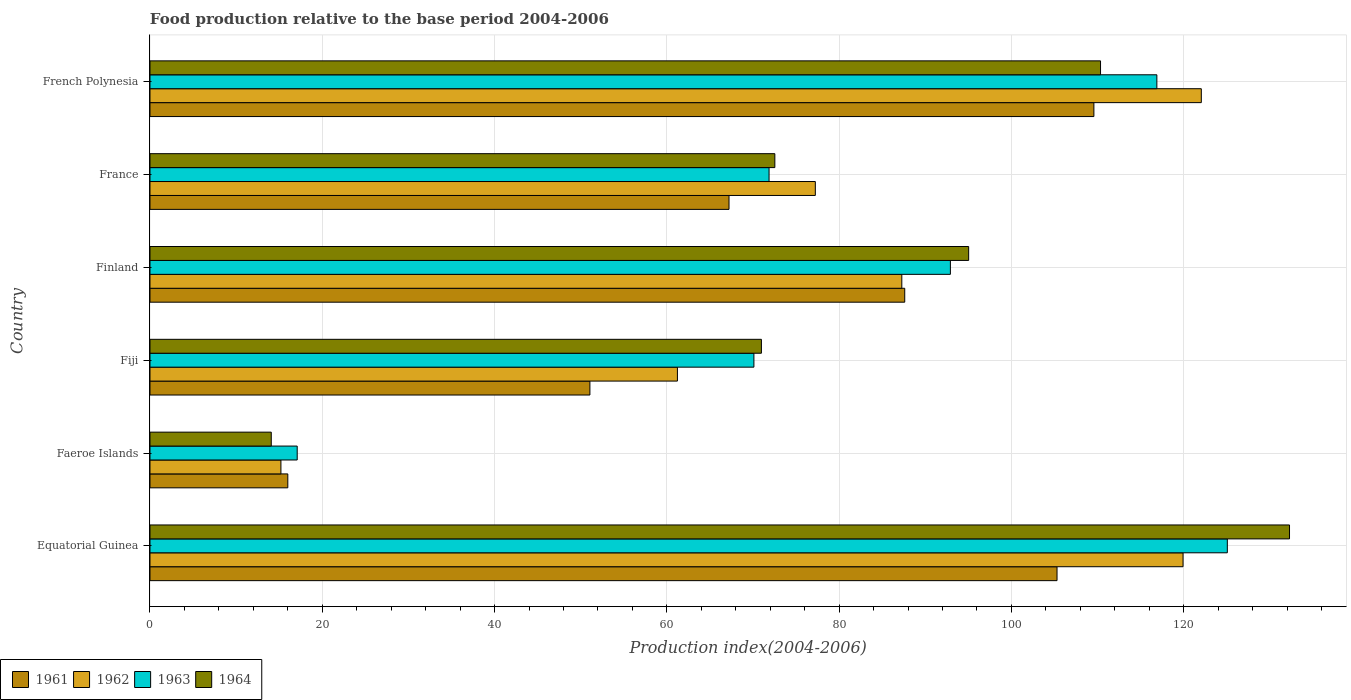How many groups of bars are there?
Ensure brevity in your answer.  6. Are the number of bars per tick equal to the number of legend labels?
Your response must be concise. Yes. Are the number of bars on each tick of the Y-axis equal?
Give a very brief answer. Yes. How many bars are there on the 3rd tick from the bottom?
Offer a terse response. 4. What is the label of the 5th group of bars from the top?
Provide a short and direct response. Faeroe Islands. What is the food production index in 1964 in Faeroe Islands?
Keep it short and to the point. 14.08. Across all countries, what is the maximum food production index in 1961?
Keep it short and to the point. 109.58. Across all countries, what is the minimum food production index in 1962?
Ensure brevity in your answer.  15.2. In which country was the food production index in 1964 maximum?
Offer a terse response. Equatorial Guinea. In which country was the food production index in 1961 minimum?
Your response must be concise. Faeroe Islands. What is the total food production index in 1964 in the graph?
Offer a very short reply. 495.28. What is the difference between the food production index in 1963 in Fiji and that in Finland?
Provide a short and direct response. -22.81. What is the difference between the food production index in 1963 in Faeroe Islands and the food production index in 1962 in Equatorial Guinea?
Ensure brevity in your answer.  -102.84. What is the average food production index in 1963 per country?
Ensure brevity in your answer.  82.33. What is the difference between the food production index in 1961 and food production index in 1964 in Equatorial Guinea?
Provide a succinct answer. -26.99. In how many countries, is the food production index in 1963 greater than 68 ?
Your answer should be compact. 5. What is the ratio of the food production index in 1961 in Equatorial Guinea to that in Finland?
Your response must be concise. 1.2. Is the difference between the food production index in 1961 in Equatorial Guinea and Finland greater than the difference between the food production index in 1964 in Equatorial Guinea and Finland?
Your answer should be compact. No. What is the difference between the highest and the second highest food production index in 1961?
Your answer should be compact. 4.28. What is the difference between the highest and the lowest food production index in 1961?
Offer a terse response. 93.58. In how many countries, is the food production index in 1962 greater than the average food production index in 1962 taken over all countries?
Offer a terse response. 3. Is the sum of the food production index in 1962 in Finland and French Polynesia greater than the maximum food production index in 1963 across all countries?
Provide a short and direct response. Yes. Is it the case that in every country, the sum of the food production index in 1961 and food production index in 1963 is greater than the sum of food production index in 1962 and food production index in 1964?
Keep it short and to the point. No. What does the 1st bar from the top in Faeroe Islands represents?
Keep it short and to the point. 1964. What does the 4th bar from the bottom in Finland represents?
Give a very brief answer. 1964. Is it the case that in every country, the sum of the food production index in 1964 and food production index in 1961 is greater than the food production index in 1962?
Your response must be concise. Yes. How many bars are there?
Make the answer very short. 24. What is the difference between two consecutive major ticks on the X-axis?
Make the answer very short. 20. Does the graph contain grids?
Your response must be concise. Yes. Where does the legend appear in the graph?
Provide a succinct answer. Bottom left. How many legend labels are there?
Your response must be concise. 4. How are the legend labels stacked?
Your answer should be very brief. Horizontal. What is the title of the graph?
Give a very brief answer. Food production relative to the base period 2004-2006. Does "2000" appear as one of the legend labels in the graph?
Make the answer very short. No. What is the label or title of the X-axis?
Offer a very short reply. Production index(2004-2006). What is the Production index(2004-2006) of 1961 in Equatorial Guinea?
Your response must be concise. 105.3. What is the Production index(2004-2006) in 1962 in Equatorial Guinea?
Your response must be concise. 119.93. What is the Production index(2004-2006) of 1963 in Equatorial Guinea?
Your answer should be very brief. 125.07. What is the Production index(2004-2006) in 1964 in Equatorial Guinea?
Offer a terse response. 132.29. What is the Production index(2004-2006) in 1962 in Faeroe Islands?
Ensure brevity in your answer.  15.2. What is the Production index(2004-2006) in 1963 in Faeroe Islands?
Provide a succinct answer. 17.09. What is the Production index(2004-2006) in 1964 in Faeroe Islands?
Your response must be concise. 14.08. What is the Production index(2004-2006) of 1961 in Fiji?
Ensure brevity in your answer.  51.07. What is the Production index(2004-2006) in 1962 in Fiji?
Ensure brevity in your answer.  61.23. What is the Production index(2004-2006) in 1963 in Fiji?
Give a very brief answer. 70.11. What is the Production index(2004-2006) of 1964 in Fiji?
Give a very brief answer. 70.98. What is the Production index(2004-2006) in 1961 in Finland?
Offer a very short reply. 87.62. What is the Production index(2004-2006) in 1962 in Finland?
Keep it short and to the point. 87.28. What is the Production index(2004-2006) of 1963 in Finland?
Offer a very short reply. 92.92. What is the Production index(2004-2006) of 1964 in Finland?
Make the answer very short. 95.04. What is the Production index(2004-2006) of 1961 in France?
Give a very brief answer. 67.22. What is the Production index(2004-2006) of 1962 in France?
Your answer should be very brief. 77.24. What is the Production index(2004-2006) in 1963 in France?
Ensure brevity in your answer.  71.87. What is the Production index(2004-2006) in 1964 in France?
Provide a short and direct response. 72.54. What is the Production index(2004-2006) of 1961 in French Polynesia?
Give a very brief answer. 109.58. What is the Production index(2004-2006) in 1962 in French Polynesia?
Offer a very short reply. 122.05. What is the Production index(2004-2006) in 1963 in French Polynesia?
Your response must be concise. 116.89. What is the Production index(2004-2006) of 1964 in French Polynesia?
Offer a very short reply. 110.35. Across all countries, what is the maximum Production index(2004-2006) of 1961?
Give a very brief answer. 109.58. Across all countries, what is the maximum Production index(2004-2006) in 1962?
Give a very brief answer. 122.05. Across all countries, what is the maximum Production index(2004-2006) in 1963?
Your answer should be compact. 125.07. Across all countries, what is the maximum Production index(2004-2006) in 1964?
Your answer should be very brief. 132.29. Across all countries, what is the minimum Production index(2004-2006) of 1963?
Your response must be concise. 17.09. Across all countries, what is the minimum Production index(2004-2006) in 1964?
Offer a very short reply. 14.08. What is the total Production index(2004-2006) in 1961 in the graph?
Your answer should be compact. 436.79. What is the total Production index(2004-2006) in 1962 in the graph?
Your answer should be very brief. 482.93. What is the total Production index(2004-2006) in 1963 in the graph?
Offer a terse response. 493.95. What is the total Production index(2004-2006) of 1964 in the graph?
Provide a succinct answer. 495.28. What is the difference between the Production index(2004-2006) of 1961 in Equatorial Guinea and that in Faeroe Islands?
Your answer should be compact. 89.3. What is the difference between the Production index(2004-2006) of 1962 in Equatorial Guinea and that in Faeroe Islands?
Make the answer very short. 104.73. What is the difference between the Production index(2004-2006) of 1963 in Equatorial Guinea and that in Faeroe Islands?
Make the answer very short. 107.98. What is the difference between the Production index(2004-2006) in 1964 in Equatorial Guinea and that in Faeroe Islands?
Provide a succinct answer. 118.21. What is the difference between the Production index(2004-2006) of 1961 in Equatorial Guinea and that in Fiji?
Offer a very short reply. 54.23. What is the difference between the Production index(2004-2006) of 1962 in Equatorial Guinea and that in Fiji?
Offer a terse response. 58.7. What is the difference between the Production index(2004-2006) of 1963 in Equatorial Guinea and that in Fiji?
Give a very brief answer. 54.96. What is the difference between the Production index(2004-2006) of 1964 in Equatorial Guinea and that in Fiji?
Keep it short and to the point. 61.31. What is the difference between the Production index(2004-2006) of 1961 in Equatorial Guinea and that in Finland?
Offer a terse response. 17.68. What is the difference between the Production index(2004-2006) in 1962 in Equatorial Guinea and that in Finland?
Your answer should be very brief. 32.65. What is the difference between the Production index(2004-2006) in 1963 in Equatorial Guinea and that in Finland?
Give a very brief answer. 32.15. What is the difference between the Production index(2004-2006) in 1964 in Equatorial Guinea and that in Finland?
Ensure brevity in your answer.  37.25. What is the difference between the Production index(2004-2006) in 1961 in Equatorial Guinea and that in France?
Your response must be concise. 38.08. What is the difference between the Production index(2004-2006) in 1962 in Equatorial Guinea and that in France?
Your answer should be compact. 42.69. What is the difference between the Production index(2004-2006) in 1963 in Equatorial Guinea and that in France?
Your response must be concise. 53.2. What is the difference between the Production index(2004-2006) of 1964 in Equatorial Guinea and that in France?
Give a very brief answer. 59.75. What is the difference between the Production index(2004-2006) in 1961 in Equatorial Guinea and that in French Polynesia?
Provide a short and direct response. -4.28. What is the difference between the Production index(2004-2006) in 1962 in Equatorial Guinea and that in French Polynesia?
Offer a terse response. -2.12. What is the difference between the Production index(2004-2006) of 1963 in Equatorial Guinea and that in French Polynesia?
Offer a very short reply. 8.18. What is the difference between the Production index(2004-2006) in 1964 in Equatorial Guinea and that in French Polynesia?
Make the answer very short. 21.94. What is the difference between the Production index(2004-2006) in 1961 in Faeroe Islands and that in Fiji?
Give a very brief answer. -35.07. What is the difference between the Production index(2004-2006) of 1962 in Faeroe Islands and that in Fiji?
Ensure brevity in your answer.  -46.03. What is the difference between the Production index(2004-2006) of 1963 in Faeroe Islands and that in Fiji?
Offer a very short reply. -53.02. What is the difference between the Production index(2004-2006) of 1964 in Faeroe Islands and that in Fiji?
Offer a terse response. -56.9. What is the difference between the Production index(2004-2006) in 1961 in Faeroe Islands and that in Finland?
Offer a terse response. -71.62. What is the difference between the Production index(2004-2006) of 1962 in Faeroe Islands and that in Finland?
Provide a short and direct response. -72.08. What is the difference between the Production index(2004-2006) in 1963 in Faeroe Islands and that in Finland?
Your answer should be very brief. -75.83. What is the difference between the Production index(2004-2006) in 1964 in Faeroe Islands and that in Finland?
Offer a terse response. -80.96. What is the difference between the Production index(2004-2006) of 1961 in Faeroe Islands and that in France?
Offer a very short reply. -51.22. What is the difference between the Production index(2004-2006) in 1962 in Faeroe Islands and that in France?
Make the answer very short. -62.04. What is the difference between the Production index(2004-2006) of 1963 in Faeroe Islands and that in France?
Provide a succinct answer. -54.78. What is the difference between the Production index(2004-2006) in 1964 in Faeroe Islands and that in France?
Offer a very short reply. -58.46. What is the difference between the Production index(2004-2006) of 1961 in Faeroe Islands and that in French Polynesia?
Ensure brevity in your answer.  -93.58. What is the difference between the Production index(2004-2006) in 1962 in Faeroe Islands and that in French Polynesia?
Provide a succinct answer. -106.85. What is the difference between the Production index(2004-2006) of 1963 in Faeroe Islands and that in French Polynesia?
Provide a succinct answer. -99.8. What is the difference between the Production index(2004-2006) of 1964 in Faeroe Islands and that in French Polynesia?
Your answer should be very brief. -96.27. What is the difference between the Production index(2004-2006) in 1961 in Fiji and that in Finland?
Make the answer very short. -36.55. What is the difference between the Production index(2004-2006) in 1962 in Fiji and that in Finland?
Your response must be concise. -26.05. What is the difference between the Production index(2004-2006) in 1963 in Fiji and that in Finland?
Your response must be concise. -22.81. What is the difference between the Production index(2004-2006) in 1964 in Fiji and that in Finland?
Provide a short and direct response. -24.06. What is the difference between the Production index(2004-2006) of 1961 in Fiji and that in France?
Make the answer very short. -16.15. What is the difference between the Production index(2004-2006) in 1962 in Fiji and that in France?
Provide a short and direct response. -16.01. What is the difference between the Production index(2004-2006) of 1963 in Fiji and that in France?
Make the answer very short. -1.76. What is the difference between the Production index(2004-2006) in 1964 in Fiji and that in France?
Offer a very short reply. -1.56. What is the difference between the Production index(2004-2006) in 1961 in Fiji and that in French Polynesia?
Your answer should be very brief. -58.51. What is the difference between the Production index(2004-2006) of 1962 in Fiji and that in French Polynesia?
Your answer should be compact. -60.82. What is the difference between the Production index(2004-2006) of 1963 in Fiji and that in French Polynesia?
Provide a short and direct response. -46.78. What is the difference between the Production index(2004-2006) in 1964 in Fiji and that in French Polynesia?
Give a very brief answer. -39.37. What is the difference between the Production index(2004-2006) in 1961 in Finland and that in France?
Keep it short and to the point. 20.4. What is the difference between the Production index(2004-2006) of 1962 in Finland and that in France?
Make the answer very short. 10.04. What is the difference between the Production index(2004-2006) of 1963 in Finland and that in France?
Keep it short and to the point. 21.05. What is the difference between the Production index(2004-2006) of 1964 in Finland and that in France?
Your answer should be very brief. 22.5. What is the difference between the Production index(2004-2006) in 1961 in Finland and that in French Polynesia?
Keep it short and to the point. -21.96. What is the difference between the Production index(2004-2006) in 1962 in Finland and that in French Polynesia?
Your response must be concise. -34.77. What is the difference between the Production index(2004-2006) in 1963 in Finland and that in French Polynesia?
Provide a succinct answer. -23.97. What is the difference between the Production index(2004-2006) in 1964 in Finland and that in French Polynesia?
Provide a succinct answer. -15.31. What is the difference between the Production index(2004-2006) in 1961 in France and that in French Polynesia?
Ensure brevity in your answer.  -42.36. What is the difference between the Production index(2004-2006) of 1962 in France and that in French Polynesia?
Provide a succinct answer. -44.81. What is the difference between the Production index(2004-2006) of 1963 in France and that in French Polynesia?
Offer a very short reply. -45.02. What is the difference between the Production index(2004-2006) of 1964 in France and that in French Polynesia?
Your response must be concise. -37.81. What is the difference between the Production index(2004-2006) in 1961 in Equatorial Guinea and the Production index(2004-2006) in 1962 in Faeroe Islands?
Provide a short and direct response. 90.1. What is the difference between the Production index(2004-2006) in 1961 in Equatorial Guinea and the Production index(2004-2006) in 1963 in Faeroe Islands?
Your answer should be compact. 88.21. What is the difference between the Production index(2004-2006) in 1961 in Equatorial Guinea and the Production index(2004-2006) in 1964 in Faeroe Islands?
Make the answer very short. 91.22. What is the difference between the Production index(2004-2006) of 1962 in Equatorial Guinea and the Production index(2004-2006) of 1963 in Faeroe Islands?
Your response must be concise. 102.84. What is the difference between the Production index(2004-2006) in 1962 in Equatorial Guinea and the Production index(2004-2006) in 1964 in Faeroe Islands?
Offer a very short reply. 105.85. What is the difference between the Production index(2004-2006) in 1963 in Equatorial Guinea and the Production index(2004-2006) in 1964 in Faeroe Islands?
Keep it short and to the point. 110.99. What is the difference between the Production index(2004-2006) of 1961 in Equatorial Guinea and the Production index(2004-2006) of 1962 in Fiji?
Give a very brief answer. 44.07. What is the difference between the Production index(2004-2006) of 1961 in Equatorial Guinea and the Production index(2004-2006) of 1963 in Fiji?
Provide a short and direct response. 35.19. What is the difference between the Production index(2004-2006) in 1961 in Equatorial Guinea and the Production index(2004-2006) in 1964 in Fiji?
Your response must be concise. 34.32. What is the difference between the Production index(2004-2006) of 1962 in Equatorial Guinea and the Production index(2004-2006) of 1963 in Fiji?
Your response must be concise. 49.82. What is the difference between the Production index(2004-2006) of 1962 in Equatorial Guinea and the Production index(2004-2006) of 1964 in Fiji?
Offer a very short reply. 48.95. What is the difference between the Production index(2004-2006) in 1963 in Equatorial Guinea and the Production index(2004-2006) in 1964 in Fiji?
Provide a short and direct response. 54.09. What is the difference between the Production index(2004-2006) of 1961 in Equatorial Guinea and the Production index(2004-2006) of 1962 in Finland?
Ensure brevity in your answer.  18.02. What is the difference between the Production index(2004-2006) of 1961 in Equatorial Guinea and the Production index(2004-2006) of 1963 in Finland?
Make the answer very short. 12.38. What is the difference between the Production index(2004-2006) of 1961 in Equatorial Guinea and the Production index(2004-2006) of 1964 in Finland?
Your answer should be compact. 10.26. What is the difference between the Production index(2004-2006) of 1962 in Equatorial Guinea and the Production index(2004-2006) of 1963 in Finland?
Provide a short and direct response. 27.01. What is the difference between the Production index(2004-2006) of 1962 in Equatorial Guinea and the Production index(2004-2006) of 1964 in Finland?
Give a very brief answer. 24.89. What is the difference between the Production index(2004-2006) of 1963 in Equatorial Guinea and the Production index(2004-2006) of 1964 in Finland?
Your answer should be compact. 30.03. What is the difference between the Production index(2004-2006) in 1961 in Equatorial Guinea and the Production index(2004-2006) in 1962 in France?
Provide a short and direct response. 28.06. What is the difference between the Production index(2004-2006) of 1961 in Equatorial Guinea and the Production index(2004-2006) of 1963 in France?
Offer a terse response. 33.43. What is the difference between the Production index(2004-2006) of 1961 in Equatorial Guinea and the Production index(2004-2006) of 1964 in France?
Provide a short and direct response. 32.76. What is the difference between the Production index(2004-2006) of 1962 in Equatorial Guinea and the Production index(2004-2006) of 1963 in France?
Provide a short and direct response. 48.06. What is the difference between the Production index(2004-2006) of 1962 in Equatorial Guinea and the Production index(2004-2006) of 1964 in France?
Provide a succinct answer. 47.39. What is the difference between the Production index(2004-2006) of 1963 in Equatorial Guinea and the Production index(2004-2006) of 1964 in France?
Offer a terse response. 52.53. What is the difference between the Production index(2004-2006) of 1961 in Equatorial Guinea and the Production index(2004-2006) of 1962 in French Polynesia?
Your response must be concise. -16.75. What is the difference between the Production index(2004-2006) of 1961 in Equatorial Guinea and the Production index(2004-2006) of 1963 in French Polynesia?
Your answer should be very brief. -11.59. What is the difference between the Production index(2004-2006) of 1961 in Equatorial Guinea and the Production index(2004-2006) of 1964 in French Polynesia?
Provide a short and direct response. -5.05. What is the difference between the Production index(2004-2006) of 1962 in Equatorial Guinea and the Production index(2004-2006) of 1963 in French Polynesia?
Provide a succinct answer. 3.04. What is the difference between the Production index(2004-2006) in 1962 in Equatorial Guinea and the Production index(2004-2006) in 1964 in French Polynesia?
Your answer should be compact. 9.58. What is the difference between the Production index(2004-2006) in 1963 in Equatorial Guinea and the Production index(2004-2006) in 1964 in French Polynesia?
Provide a short and direct response. 14.72. What is the difference between the Production index(2004-2006) in 1961 in Faeroe Islands and the Production index(2004-2006) in 1962 in Fiji?
Provide a short and direct response. -45.23. What is the difference between the Production index(2004-2006) in 1961 in Faeroe Islands and the Production index(2004-2006) in 1963 in Fiji?
Your response must be concise. -54.11. What is the difference between the Production index(2004-2006) in 1961 in Faeroe Islands and the Production index(2004-2006) in 1964 in Fiji?
Your answer should be compact. -54.98. What is the difference between the Production index(2004-2006) in 1962 in Faeroe Islands and the Production index(2004-2006) in 1963 in Fiji?
Keep it short and to the point. -54.91. What is the difference between the Production index(2004-2006) of 1962 in Faeroe Islands and the Production index(2004-2006) of 1964 in Fiji?
Keep it short and to the point. -55.78. What is the difference between the Production index(2004-2006) of 1963 in Faeroe Islands and the Production index(2004-2006) of 1964 in Fiji?
Ensure brevity in your answer.  -53.89. What is the difference between the Production index(2004-2006) of 1961 in Faeroe Islands and the Production index(2004-2006) of 1962 in Finland?
Offer a terse response. -71.28. What is the difference between the Production index(2004-2006) in 1961 in Faeroe Islands and the Production index(2004-2006) in 1963 in Finland?
Give a very brief answer. -76.92. What is the difference between the Production index(2004-2006) of 1961 in Faeroe Islands and the Production index(2004-2006) of 1964 in Finland?
Make the answer very short. -79.04. What is the difference between the Production index(2004-2006) of 1962 in Faeroe Islands and the Production index(2004-2006) of 1963 in Finland?
Offer a very short reply. -77.72. What is the difference between the Production index(2004-2006) of 1962 in Faeroe Islands and the Production index(2004-2006) of 1964 in Finland?
Provide a short and direct response. -79.84. What is the difference between the Production index(2004-2006) of 1963 in Faeroe Islands and the Production index(2004-2006) of 1964 in Finland?
Offer a terse response. -77.95. What is the difference between the Production index(2004-2006) in 1961 in Faeroe Islands and the Production index(2004-2006) in 1962 in France?
Provide a short and direct response. -61.24. What is the difference between the Production index(2004-2006) in 1961 in Faeroe Islands and the Production index(2004-2006) in 1963 in France?
Provide a short and direct response. -55.87. What is the difference between the Production index(2004-2006) in 1961 in Faeroe Islands and the Production index(2004-2006) in 1964 in France?
Offer a very short reply. -56.54. What is the difference between the Production index(2004-2006) of 1962 in Faeroe Islands and the Production index(2004-2006) of 1963 in France?
Your answer should be compact. -56.67. What is the difference between the Production index(2004-2006) in 1962 in Faeroe Islands and the Production index(2004-2006) in 1964 in France?
Your response must be concise. -57.34. What is the difference between the Production index(2004-2006) of 1963 in Faeroe Islands and the Production index(2004-2006) of 1964 in France?
Make the answer very short. -55.45. What is the difference between the Production index(2004-2006) in 1961 in Faeroe Islands and the Production index(2004-2006) in 1962 in French Polynesia?
Make the answer very short. -106.05. What is the difference between the Production index(2004-2006) in 1961 in Faeroe Islands and the Production index(2004-2006) in 1963 in French Polynesia?
Provide a short and direct response. -100.89. What is the difference between the Production index(2004-2006) of 1961 in Faeroe Islands and the Production index(2004-2006) of 1964 in French Polynesia?
Keep it short and to the point. -94.35. What is the difference between the Production index(2004-2006) in 1962 in Faeroe Islands and the Production index(2004-2006) in 1963 in French Polynesia?
Keep it short and to the point. -101.69. What is the difference between the Production index(2004-2006) of 1962 in Faeroe Islands and the Production index(2004-2006) of 1964 in French Polynesia?
Your answer should be compact. -95.15. What is the difference between the Production index(2004-2006) of 1963 in Faeroe Islands and the Production index(2004-2006) of 1964 in French Polynesia?
Provide a succinct answer. -93.26. What is the difference between the Production index(2004-2006) in 1961 in Fiji and the Production index(2004-2006) in 1962 in Finland?
Give a very brief answer. -36.21. What is the difference between the Production index(2004-2006) in 1961 in Fiji and the Production index(2004-2006) in 1963 in Finland?
Your response must be concise. -41.85. What is the difference between the Production index(2004-2006) in 1961 in Fiji and the Production index(2004-2006) in 1964 in Finland?
Provide a succinct answer. -43.97. What is the difference between the Production index(2004-2006) in 1962 in Fiji and the Production index(2004-2006) in 1963 in Finland?
Your response must be concise. -31.69. What is the difference between the Production index(2004-2006) of 1962 in Fiji and the Production index(2004-2006) of 1964 in Finland?
Give a very brief answer. -33.81. What is the difference between the Production index(2004-2006) of 1963 in Fiji and the Production index(2004-2006) of 1964 in Finland?
Offer a very short reply. -24.93. What is the difference between the Production index(2004-2006) in 1961 in Fiji and the Production index(2004-2006) in 1962 in France?
Offer a very short reply. -26.17. What is the difference between the Production index(2004-2006) of 1961 in Fiji and the Production index(2004-2006) of 1963 in France?
Provide a succinct answer. -20.8. What is the difference between the Production index(2004-2006) in 1961 in Fiji and the Production index(2004-2006) in 1964 in France?
Your response must be concise. -21.47. What is the difference between the Production index(2004-2006) of 1962 in Fiji and the Production index(2004-2006) of 1963 in France?
Provide a succinct answer. -10.64. What is the difference between the Production index(2004-2006) in 1962 in Fiji and the Production index(2004-2006) in 1964 in France?
Provide a short and direct response. -11.31. What is the difference between the Production index(2004-2006) of 1963 in Fiji and the Production index(2004-2006) of 1964 in France?
Offer a very short reply. -2.43. What is the difference between the Production index(2004-2006) in 1961 in Fiji and the Production index(2004-2006) in 1962 in French Polynesia?
Offer a very short reply. -70.98. What is the difference between the Production index(2004-2006) in 1961 in Fiji and the Production index(2004-2006) in 1963 in French Polynesia?
Make the answer very short. -65.82. What is the difference between the Production index(2004-2006) of 1961 in Fiji and the Production index(2004-2006) of 1964 in French Polynesia?
Ensure brevity in your answer.  -59.28. What is the difference between the Production index(2004-2006) in 1962 in Fiji and the Production index(2004-2006) in 1963 in French Polynesia?
Your response must be concise. -55.66. What is the difference between the Production index(2004-2006) of 1962 in Fiji and the Production index(2004-2006) of 1964 in French Polynesia?
Offer a very short reply. -49.12. What is the difference between the Production index(2004-2006) in 1963 in Fiji and the Production index(2004-2006) in 1964 in French Polynesia?
Offer a terse response. -40.24. What is the difference between the Production index(2004-2006) in 1961 in Finland and the Production index(2004-2006) in 1962 in France?
Provide a succinct answer. 10.38. What is the difference between the Production index(2004-2006) of 1961 in Finland and the Production index(2004-2006) of 1963 in France?
Offer a very short reply. 15.75. What is the difference between the Production index(2004-2006) of 1961 in Finland and the Production index(2004-2006) of 1964 in France?
Give a very brief answer. 15.08. What is the difference between the Production index(2004-2006) in 1962 in Finland and the Production index(2004-2006) in 1963 in France?
Ensure brevity in your answer.  15.41. What is the difference between the Production index(2004-2006) in 1962 in Finland and the Production index(2004-2006) in 1964 in France?
Your answer should be compact. 14.74. What is the difference between the Production index(2004-2006) in 1963 in Finland and the Production index(2004-2006) in 1964 in France?
Your answer should be compact. 20.38. What is the difference between the Production index(2004-2006) of 1961 in Finland and the Production index(2004-2006) of 1962 in French Polynesia?
Keep it short and to the point. -34.43. What is the difference between the Production index(2004-2006) of 1961 in Finland and the Production index(2004-2006) of 1963 in French Polynesia?
Give a very brief answer. -29.27. What is the difference between the Production index(2004-2006) of 1961 in Finland and the Production index(2004-2006) of 1964 in French Polynesia?
Offer a terse response. -22.73. What is the difference between the Production index(2004-2006) of 1962 in Finland and the Production index(2004-2006) of 1963 in French Polynesia?
Your response must be concise. -29.61. What is the difference between the Production index(2004-2006) in 1962 in Finland and the Production index(2004-2006) in 1964 in French Polynesia?
Provide a succinct answer. -23.07. What is the difference between the Production index(2004-2006) of 1963 in Finland and the Production index(2004-2006) of 1964 in French Polynesia?
Provide a short and direct response. -17.43. What is the difference between the Production index(2004-2006) in 1961 in France and the Production index(2004-2006) in 1962 in French Polynesia?
Provide a succinct answer. -54.83. What is the difference between the Production index(2004-2006) of 1961 in France and the Production index(2004-2006) of 1963 in French Polynesia?
Give a very brief answer. -49.67. What is the difference between the Production index(2004-2006) in 1961 in France and the Production index(2004-2006) in 1964 in French Polynesia?
Your answer should be very brief. -43.13. What is the difference between the Production index(2004-2006) in 1962 in France and the Production index(2004-2006) in 1963 in French Polynesia?
Offer a very short reply. -39.65. What is the difference between the Production index(2004-2006) of 1962 in France and the Production index(2004-2006) of 1964 in French Polynesia?
Offer a terse response. -33.11. What is the difference between the Production index(2004-2006) of 1963 in France and the Production index(2004-2006) of 1964 in French Polynesia?
Your response must be concise. -38.48. What is the average Production index(2004-2006) of 1961 per country?
Provide a short and direct response. 72.8. What is the average Production index(2004-2006) in 1962 per country?
Make the answer very short. 80.49. What is the average Production index(2004-2006) of 1963 per country?
Your answer should be very brief. 82.33. What is the average Production index(2004-2006) in 1964 per country?
Your answer should be very brief. 82.55. What is the difference between the Production index(2004-2006) of 1961 and Production index(2004-2006) of 1962 in Equatorial Guinea?
Provide a short and direct response. -14.63. What is the difference between the Production index(2004-2006) in 1961 and Production index(2004-2006) in 1963 in Equatorial Guinea?
Provide a succinct answer. -19.77. What is the difference between the Production index(2004-2006) of 1961 and Production index(2004-2006) of 1964 in Equatorial Guinea?
Give a very brief answer. -26.99. What is the difference between the Production index(2004-2006) in 1962 and Production index(2004-2006) in 1963 in Equatorial Guinea?
Your response must be concise. -5.14. What is the difference between the Production index(2004-2006) in 1962 and Production index(2004-2006) in 1964 in Equatorial Guinea?
Provide a succinct answer. -12.36. What is the difference between the Production index(2004-2006) of 1963 and Production index(2004-2006) of 1964 in Equatorial Guinea?
Ensure brevity in your answer.  -7.22. What is the difference between the Production index(2004-2006) in 1961 and Production index(2004-2006) in 1962 in Faeroe Islands?
Your answer should be very brief. 0.8. What is the difference between the Production index(2004-2006) of 1961 and Production index(2004-2006) of 1963 in Faeroe Islands?
Your answer should be compact. -1.09. What is the difference between the Production index(2004-2006) of 1961 and Production index(2004-2006) of 1964 in Faeroe Islands?
Offer a very short reply. 1.92. What is the difference between the Production index(2004-2006) of 1962 and Production index(2004-2006) of 1963 in Faeroe Islands?
Give a very brief answer. -1.89. What is the difference between the Production index(2004-2006) in 1962 and Production index(2004-2006) in 1964 in Faeroe Islands?
Your response must be concise. 1.12. What is the difference between the Production index(2004-2006) in 1963 and Production index(2004-2006) in 1964 in Faeroe Islands?
Your answer should be compact. 3.01. What is the difference between the Production index(2004-2006) of 1961 and Production index(2004-2006) of 1962 in Fiji?
Give a very brief answer. -10.16. What is the difference between the Production index(2004-2006) in 1961 and Production index(2004-2006) in 1963 in Fiji?
Keep it short and to the point. -19.04. What is the difference between the Production index(2004-2006) in 1961 and Production index(2004-2006) in 1964 in Fiji?
Give a very brief answer. -19.91. What is the difference between the Production index(2004-2006) in 1962 and Production index(2004-2006) in 1963 in Fiji?
Your answer should be very brief. -8.88. What is the difference between the Production index(2004-2006) of 1962 and Production index(2004-2006) of 1964 in Fiji?
Make the answer very short. -9.75. What is the difference between the Production index(2004-2006) of 1963 and Production index(2004-2006) of 1964 in Fiji?
Offer a terse response. -0.87. What is the difference between the Production index(2004-2006) in 1961 and Production index(2004-2006) in 1962 in Finland?
Your response must be concise. 0.34. What is the difference between the Production index(2004-2006) of 1961 and Production index(2004-2006) of 1964 in Finland?
Provide a short and direct response. -7.42. What is the difference between the Production index(2004-2006) in 1962 and Production index(2004-2006) in 1963 in Finland?
Provide a succinct answer. -5.64. What is the difference between the Production index(2004-2006) of 1962 and Production index(2004-2006) of 1964 in Finland?
Make the answer very short. -7.76. What is the difference between the Production index(2004-2006) of 1963 and Production index(2004-2006) of 1964 in Finland?
Your answer should be compact. -2.12. What is the difference between the Production index(2004-2006) in 1961 and Production index(2004-2006) in 1962 in France?
Your answer should be compact. -10.02. What is the difference between the Production index(2004-2006) of 1961 and Production index(2004-2006) of 1963 in France?
Ensure brevity in your answer.  -4.65. What is the difference between the Production index(2004-2006) in 1961 and Production index(2004-2006) in 1964 in France?
Ensure brevity in your answer.  -5.32. What is the difference between the Production index(2004-2006) in 1962 and Production index(2004-2006) in 1963 in France?
Give a very brief answer. 5.37. What is the difference between the Production index(2004-2006) in 1962 and Production index(2004-2006) in 1964 in France?
Offer a very short reply. 4.7. What is the difference between the Production index(2004-2006) in 1963 and Production index(2004-2006) in 1964 in France?
Your answer should be compact. -0.67. What is the difference between the Production index(2004-2006) in 1961 and Production index(2004-2006) in 1962 in French Polynesia?
Provide a short and direct response. -12.47. What is the difference between the Production index(2004-2006) in 1961 and Production index(2004-2006) in 1963 in French Polynesia?
Keep it short and to the point. -7.31. What is the difference between the Production index(2004-2006) of 1961 and Production index(2004-2006) of 1964 in French Polynesia?
Ensure brevity in your answer.  -0.77. What is the difference between the Production index(2004-2006) of 1962 and Production index(2004-2006) of 1963 in French Polynesia?
Your answer should be compact. 5.16. What is the difference between the Production index(2004-2006) in 1963 and Production index(2004-2006) in 1964 in French Polynesia?
Your answer should be compact. 6.54. What is the ratio of the Production index(2004-2006) of 1961 in Equatorial Guinea to that in Faeroe Islands?
Ensure brevity in your answer.  6.58. What is the ratio of the Production index(2004-2006) in 1962 in Equatorial Guinea to that in Faeroe Islands?
Your answer should be compact. 7.89. What is the ratio of the Production index(2004-2006) in 1963 in Equatorial Guinea to that in Faeroe Islands?
Your answer should be very brief. 7.32. What is the ratio of the Production index(2004-2006) in 1964 in Equatorial Guinea to that in Faeroe Islands?
Make the answer very short. 9.4. What is the ratio of the Production index(2004-2006) of 1961 in Equatorial Guinea to that in Fiji?
Your answer should be very brief. 2.06. What is the ratio of the Production index(2004-2006) in 1962 in Equatorial Guinea to that in Fiji?
Your answer should be very brief. 1.96. What is the ratio of the Production index(2004-2006) in 1963 in Equatorial Guinea to that in Fiji?
Your answer should be compact. 1.78. What is the ratio of the Production index(2004-2006) in 1964 in Equatorial Guinea to that in Fiji?
Your answer should be compact. 1.86. What is the ratio of the Production index(2004-2006) in 1961 in Equatorial Guinea to that in Finland?
Provide a short and direct response. 1.2. What is the ratio of the Production index(2004-2006) in 1962 in Equatorial Guinea to that in Finland?
Offer a very short reply. 1.37. What is the ratio of the Production index(2004-2006) of 1963 in Equatorial Guinea to that in Finland?
Give a very brief answer. 1.35. What is the ratio of the Production index(2004-2006) of 1964 in Equatorial Guinea to that in Finland?
Your response must be concise. 1.39. What is the ratio of the Production index(2004-2006) in 1961 in Equatorial Guinea to that in France?
Offer a terse response. 1.57. What is the ratio of the Production index(2004-2006) of 1962 in Equatorial Guinea to that in France?
Give a very brief answer. 1.55. What is the ratio of the Production index(2004-2006) in 1963 in Equatorial Guinea to that in France?
Make the answer very short. 1.74. What is the ratio of the Production index(2004-2006) of 1964 in Equatorial Guinea to that in France?
Provide a succinct answer. 1.82. What is the ratio of the Production index(2004-2006) of 1961 in Equatorial Guinea to that in French Polynesia?
Provide a short and direct response. 0.96. What is the ratio of the Production index(2004-2006) of 1962 in Equatorial Guinea to that in French Polynesia?
Provide a short and direct response. 0.98. What is the ratio of the Production index(2004-2006) in 1963 in Equatorial Guinea to that in French Polynesia?
Make the answer very short. 1.07. What is the ratio of the Production index(2004-2006) of 1964 in Equatorial Guinea to that in French Polynesia?
Your answer should be compact. 1.2. What is the ratio of the Production index(2004-2006) in 1961 in Faeroe Islands to that in Fiji?
Provide a short and direct response. 0.31. What is the ratio of the Production index(2004-2006) of 1962 in Faeroe Islands to that in Fiji?
Provide a short and direct response. 0.25. What is the ratio of the Production index(2004-2006) of 1963 in Faeroe Islands to that in Fiji?
Make the answer very short. 0.24. What is the ratio of the Production index(2004-2006) in 1964 in Faeroe Islands to that in Fiji?
Give a very brief answer. 0.2. What is the ratio of the Production index(2004-2006) of 1961 in Faeroe Islands to that in Finland?
Give a very brief answer. 0.18. What is the ratio of the Production index(2004-2006) in 1962 in Faeroe Islands to that in Finland?
Provide a short and direct response. 0.17. What is the ratio of the Production index(2004-2006) of 1963 in Faeroe Islands to that in Finland?
Provide a succinct answer. 0.18. What is the ratio of the Production index(2004-2006) in 1964 in Faeroe Islands to that in Finland?
Offer a very short reply. 0.15. What is the ratio of the Production index(2004-2006) of 1961 in Faeroe Islands to that in France?
Make the answer very short. 0.24. What is the ratio of the Production index(2004-2006) of 1962 in Faeroe Islands to that in France?
Offer a very short reply. 0.2. What is the ratio of the Production index(2004-2006) of 1963 in Faeroe Islands to that in France?
Provide a short and direct response. 0.24. What is the ratio of the Production index(2004-2006) of 1964 in Faeroe Islands to that in France?
Offer a terse response. 0.19. What is the ratio of the Production index(2004-2006) in 1961 in Faeroe Islands to that in French Polynesia?
Provide a short and direct response. 0.15. What is the ratio of the Production index(2004-2006) in 1962 in Faeroe Islands to that in French Polynesia?
Provide a short and direct response. 0.12. What is the ratio of the Production index(2004-2006) of 1963 in Faeroe Islands to that in French Polynesia?
Offer a very short reply. 0.15. What is the ratio of the Production index(2004-2006) in 1964 in Faeroe Islands to that in French Polynesia?
Provide a short and direct response. 0.13. What is the ratio of the Production index(2004-2006) of 1961 in Fiji to that in Finland?
Ensure brevity in your answer.  0.58. What is the ratio of the Production index(2004-2006) of 1962 in Fiji to that in Finland?
Offer a terse response. 0.7. What is the ratio of the Production index(2004-2006) of 1963 in Fiji to that in Finland?
Give a very brief answer. 0.75. What is the ratio of the Production index(2004-2006) of 1964 in Fiji to that in Finland?
Offer a very short reply. 0.75. What is the ratio of the Production index(2004-2006) of 1961 in Fiji to that in France?
Your response must be concise. 0.76. What is the ratio of the Production index(2004-2006) in 1962 in Fiji to that in France?
Offer a terse response. 0.79. What is the ratio of the Production index(2004-2006) in 1963 in Fiji to that in France?
Give a very brief answer. 0.98. What is the ratio of the Production index(2004-2006) in 1964 in Fiji to that in France?
Make the answer very short. 0.98. What is the ratio of the Production index(2004-2006) in 1961 in Fiji to that in French Polynesia?
Keep it short and to the point. 0.47. What is the ratio of the Production index(2004-2006) of 1962 in Fiji to that in French Polynesia?
Your answer should be very brief. 0.5. What is the ratio of the Production index(2004-2006) in 1963 in Fiji to that in French Polynesia?
Your response must be concise. 0.6. What is the ratio of the Production index(2004-2006) of 1964 in Fiji to that in French Polynesia?
Your answer should be compact. 0.64. What is the ratio of the Production index(2004-2006) of 1961 in Finland to that in France?
Offer a very short reply. 1.3. What is the ratio of the Production index(2004-2006) of 1962 in Finland to that in France?
Your answer should be very brief. 1.13. What is the ratio of the Production index(2004-2006) in 1963 in Finland to that in France?
Your answer should be compact. 1.29. What is the ratio of the Production index(2004-2006) of 1964 in Finland to that in France?
Offer a very short reply. 1.31. What is the ratio of the Production index(2004-2006) in 1961 in Finland to that in French Polynesia?
Your answer should be compact. 0.8. What is the ratio of the Production index(2004-2006) in 1962 in Finland to that in French Polynesia?
Make the answer very short. 0.72. What is the ratio of the Production index(2004-2006) of 1963 in Finland to that in French Polynesia?
Your answer should be very brief. 0.79. What is the ratio of the Production index(2004-2006) in 1964 in Finland to that in French Polynesia?
Provide a succinct answer. 0.86. What is the ratio of the Production index(2004-2006) of 1961 in France to that in French Polynesia?
Offer a terse response. 0.61. What is the ratio of the Production index(2004-2006) in 1962 in France to that in French Polynesia?
Your answer should be very brief. 0.63. What is the ratio of the Production index(2004-2006) of 1963 in France to that in French Polynesia?
Provide a succinct answer. 0.61. What is the ratio of the Production index(2004-2006) in 1964 in France to that in French Polynesia?
Ensure brevity in your answer.  0.66. What is the difference between the highest and the second highest Production index(2004-2006) of 1961?
Provide a succinct answer. 4.28. What is the difference between the highest and the second highest Production index(2004-2006) in 1962?
Offer a very short reply. 2.12. What is the difference between the highest and the second highest Production index(2004-2006) in 1963?
Give a very brief answer. 8.18. What is the difference between the highest and the second highest Production index(2004-2006) of 1964?
Provide a succinct answer. 21.94. What is the difference between the highest and the lowest Production index(2004-2006) of 1961?
Provide a short and direct response. 93.58. What is the difference between the highest and the lowest Production index(2004-2006) in 1962?
Keep it short and to the point. 106.85. What is the difference between the highest and the lowest Production index(2004-2006) of 1963?
Offer a very short reply. 107.98. What is the difference between the highest and the lowest Production index(2004-2006) in 1964?
Offer a terse response. 118.21. 